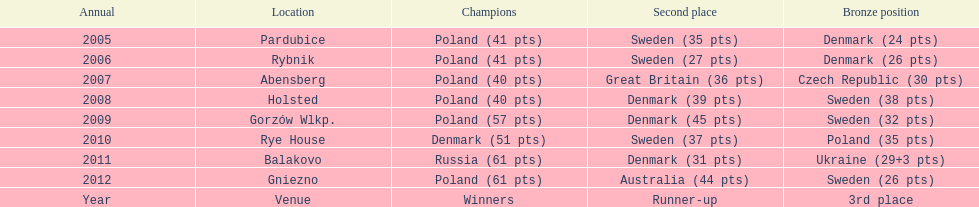What was the last year 3rd place finished with less than 25 points? 2005. 